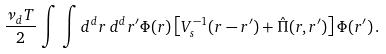Convert formula to latex. <formula><loc_0><loc_0><loc_500><loc_500>\frac { \nu _ { d } T } { 2 } \, \int \, \int d ^ { d } r \, d ^ { d } r ^ { \prime } \Phi ( r ) \left [ V _ { s } ^ { - 1 } ( r - r ^ { \prime } ) + \hat { \Pi } ( r , r ^ { \prime } ) \right ] \Phi ( r ^ { \prime } ) \, .</formula> 